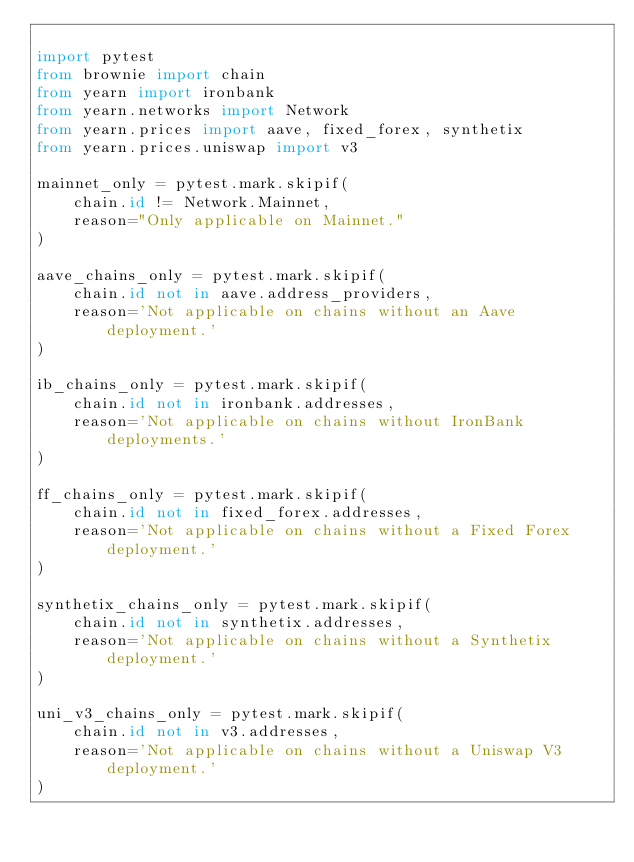Convert code to text. <code><loc_0><loc_0><loc_500><loc_500><_Python_>
import pytest
from brownie import chain
from yearn import ironbank
from yearn.networks import Network
from yearn.prices import aave, fixed_forex, synthetix
from yearn.prices.uniswap import v3

mainnet_only = pytest.mark.skipif(
    chain.id != Network.Mainnet,
    reason="Only applicable on Mainnet."
)

aave_chains_only = pytest.mark.skipif(
    chain.id not in aave.address_providers,
    reason='Not applicable on chains without an Aave deployment.'
)

ib_chains_only = pytest.mark.skipif(
    chain.id not in ironbank.addresses,
    reason='Not applicable on chains without IronBank deployments.'
)

ff_chains_only = pytest.mark.skipif(
    chain.id not in fixed_forex.addresses,
    reason='Not applicable on chains without a Fixed Forex deployment.'
)

synthetix_chains_only = pytest.mark.skipif(
    chain.id not in synthetix.addresses,
    reason='Not applicable on chains without a Synthetix deployment.'
)

uni_v3_chains_only = pytest.mark.skipif(
    chain.id not in v3.addresses,
    reason='Not applicable on chains without a Uniswap V3 deployment.'
)
</code> 